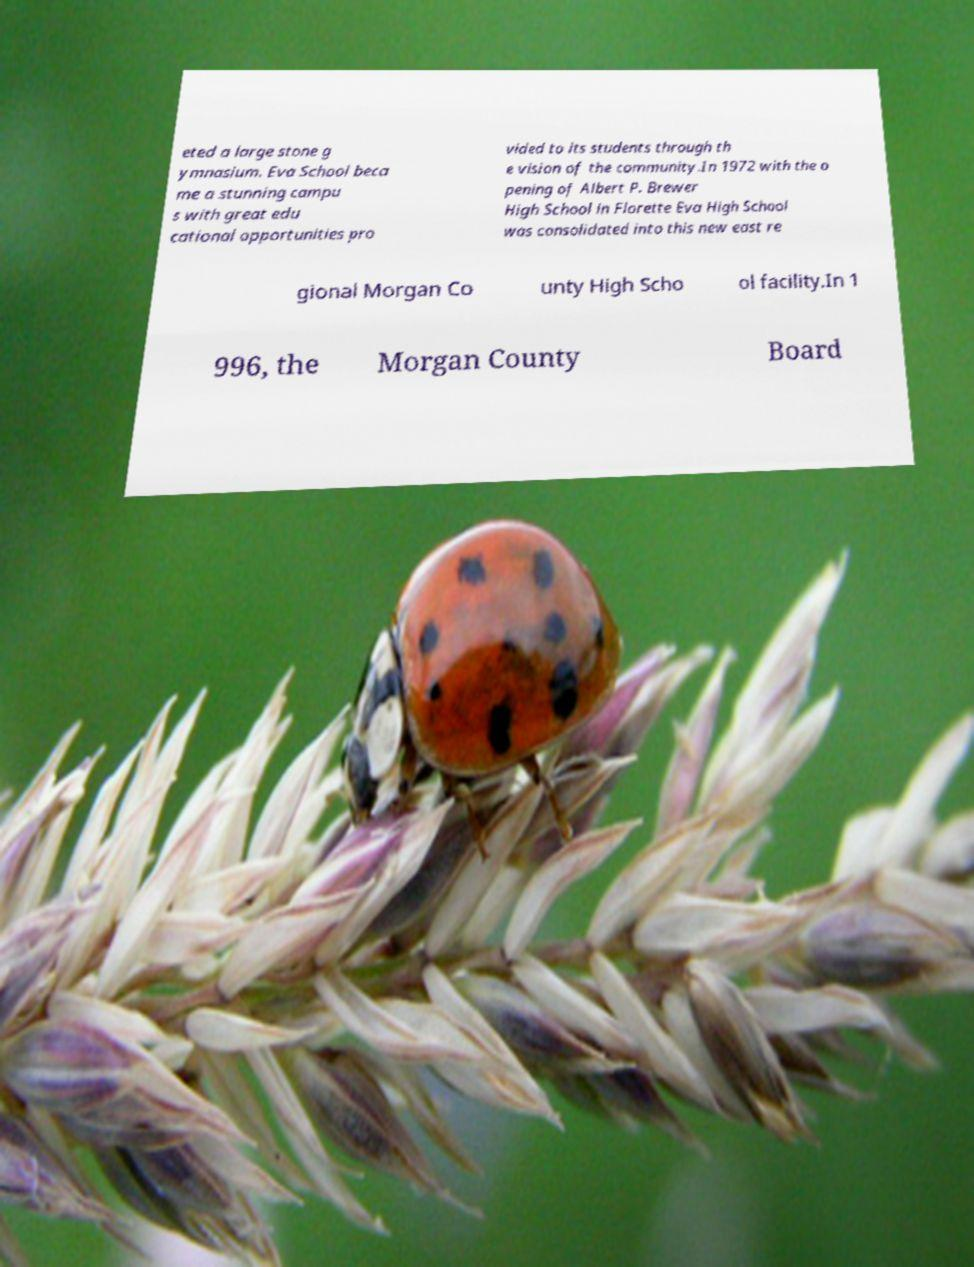Could you extract and type out the text from this image? eted a large stone g ymnasium. Eva School beca me a stunning campu s with great edu cational opportunities pro vided to its students through th e vision of the community.In 1972 with the o pening of Albert P. Brewer High School in Florette Eva High School was consolidated into this new east re gional Morgan Co unty High Scho ol facility.In 1 996, the Morgan County Board 